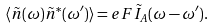<formula> <loc_0><loc_0><loc_500><loc_500>\langle \tilde { n } ( \omega ) \tilde { n } ^ { * } ( \omega ^ { \prime } ) \rangle = e F \tilde { I } _ { A } ( \omega - \omega ^ { \prime } ) .</formula> 